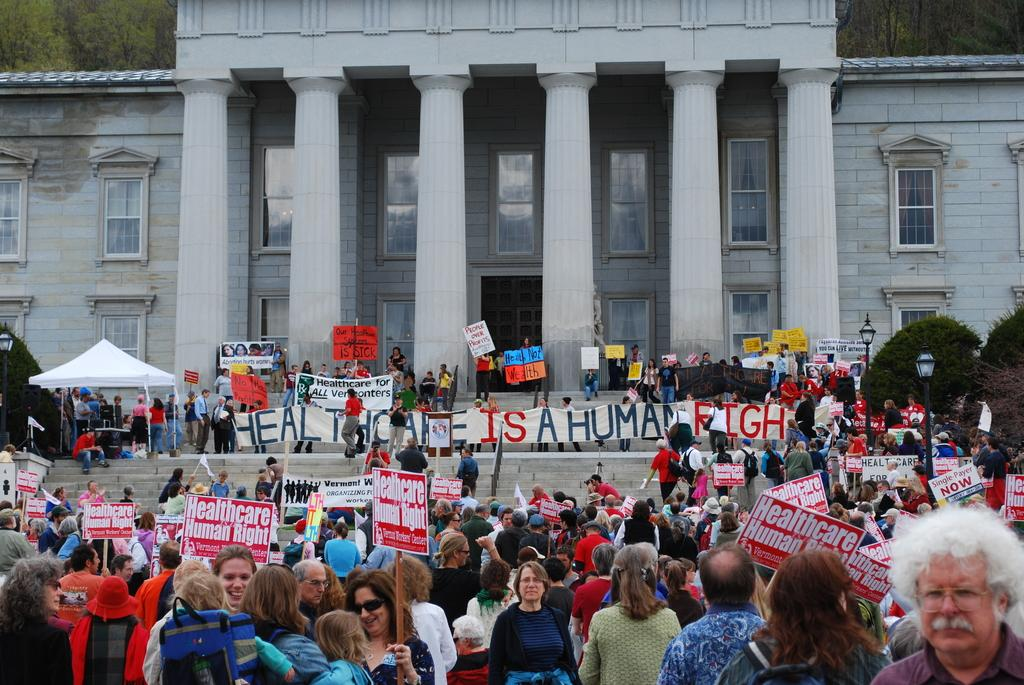How many people are present in the image? There are many people in the image. What are the people doing in the image? The people are standing all over the place and holding banners. What is the purpose of the banners? The people are protesting, and the banners are likely used to convey their message or demands. What can be seen in the background of the image? There is a building with many windows in the background of the image. How many eyes can be seen on the cook in the image? There is no cook present in the image, and therefore no eyes to count. 